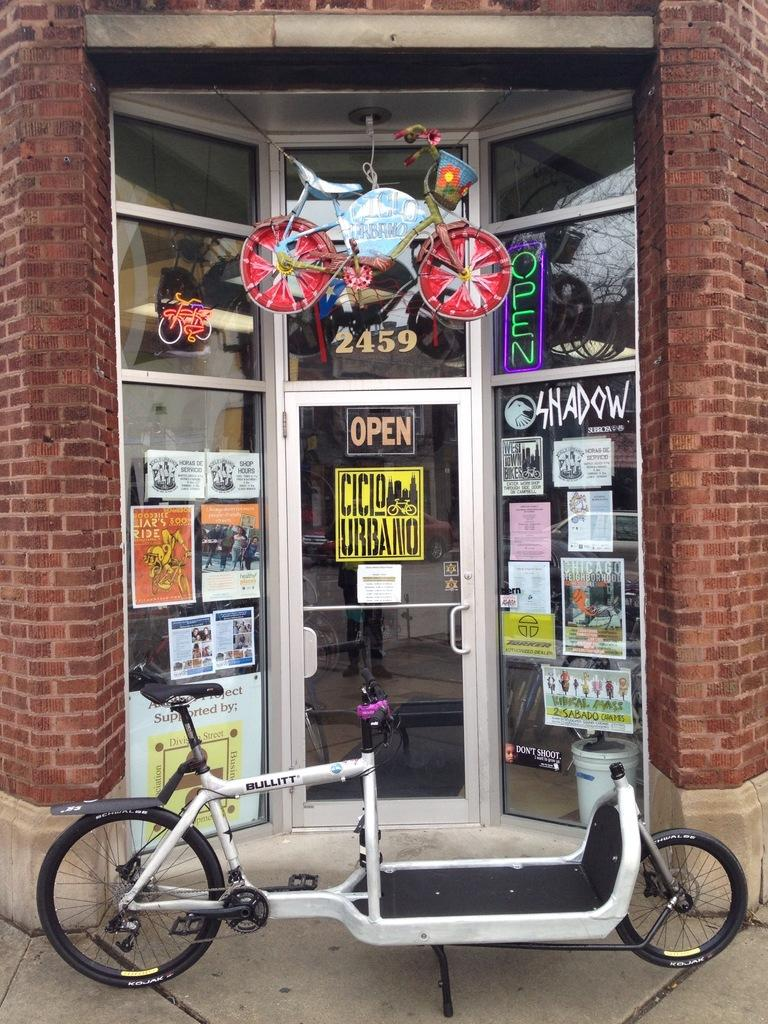What type of vehicles are in the image? There are cycles in the image. What type of door is visible in the image? There is a glass door in the image. What can be seen on the walls in the image? There are posters in the image. What is written on the posters? Text is written on the posters. What type of insect is crawling on the cycle in the image? There is no insect visible in the image; it only features cycles, a glass door, and posters. 